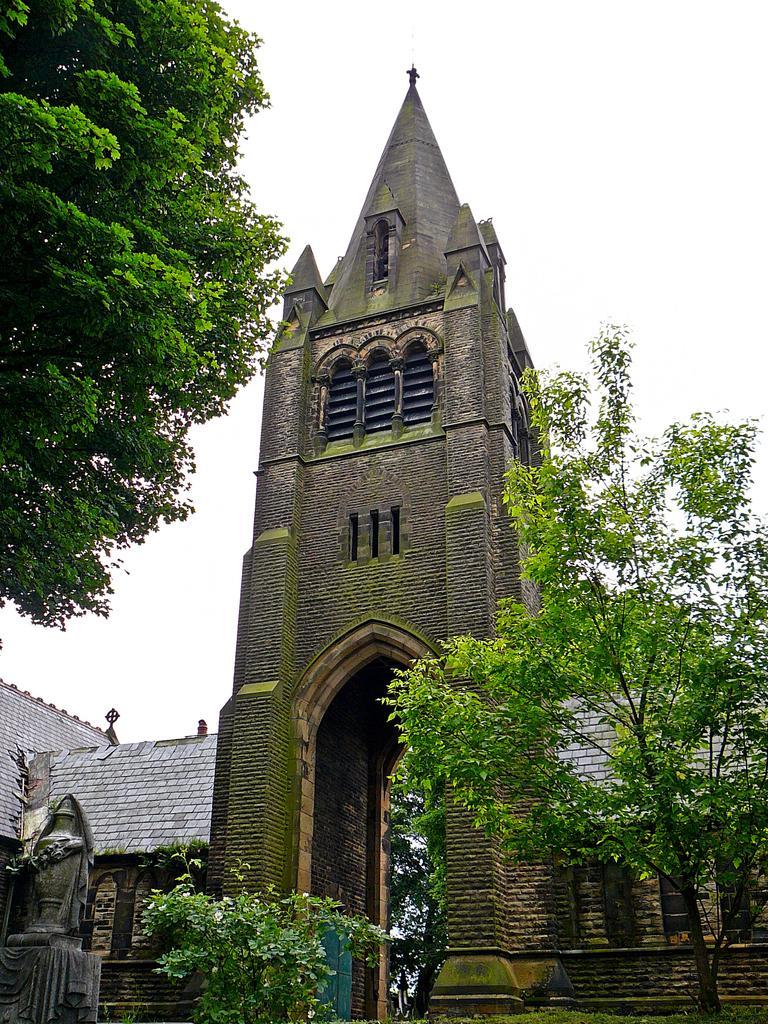Could you give a brief overview of what you see in this image? In the picture there is an architecture and around that architecture there are trees and there is a sculpture on the left side. 